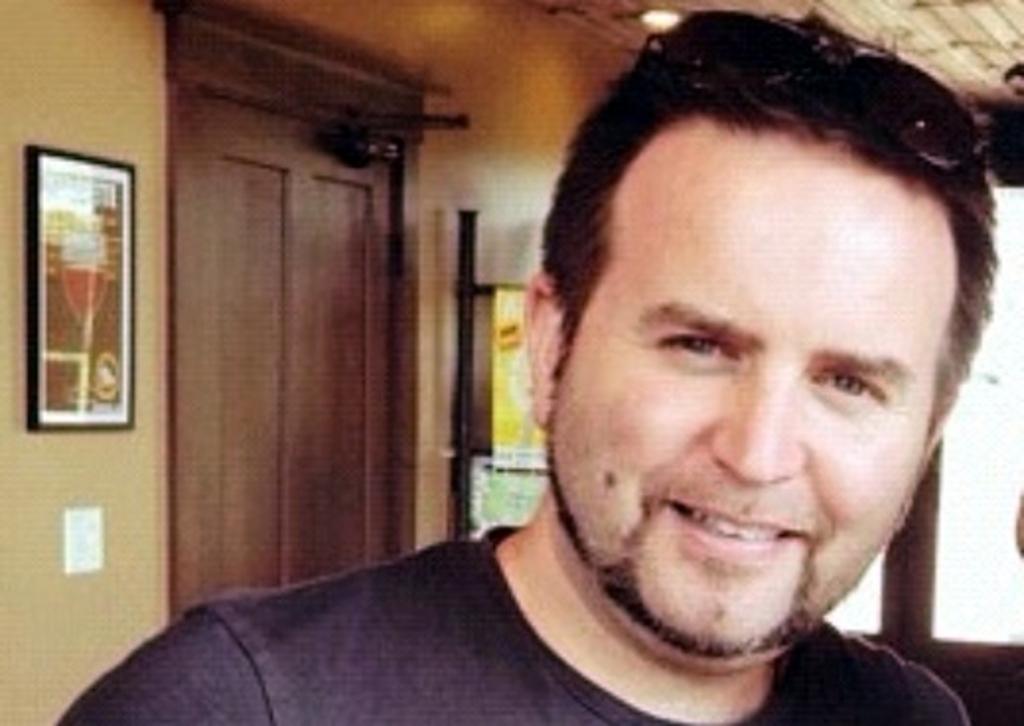Could you give a brief overview of what you see in this image? In this image, we can see a man smiling and in the background, there is a frame placed on the wall and there is a door. 